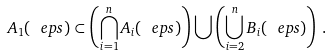Convert formula to latex. <formula><loc_0><loc_0><loc_500><loc_500>A _ { 1 } ( \ e p s ) \subset \left ( \bigcap _ { i = 1 } ^ { n } A _ { i } ( \ e p s ) \right ) \bigcup \left ( \bigcup _ { i = 2 } ^ { n } B _ { i } ( \ e p s ) \right ) \, .</formula> 